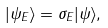Convert formula to latex. <formula><loc_0><loc_0><loc_500><loc_500>| \psi _ { E } \rangle = \sigma _ { E } | \psi \rangle ,</formula> 